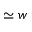<formula> <loc_0><loc_0><loc_500><loc_500>\simeq w</formula> 